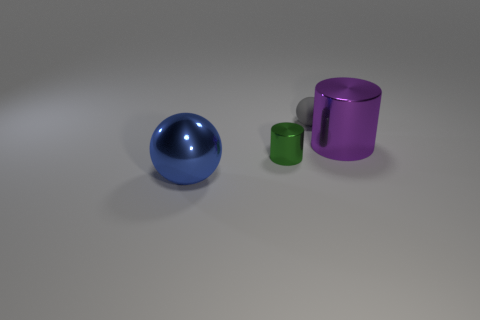Add 3 small red matte spheres. How many objects exist? 7 Subtract all purple cylinders. Subtract all cyan cubes. How many cylinders are left? 1 Subtract all blue cylinders. How many yellow spheres are left? 0 Subtract all tiny green spheres. Subtract all small green cylinders. How many objects are left? 3 Add 3 green cylinders. How many green cylinders are left? 4 Add 2 tiny shiny objects. How many tiny shiny objects exist? 3 Subtract 1 blue spheres. How many objects are left? 3 